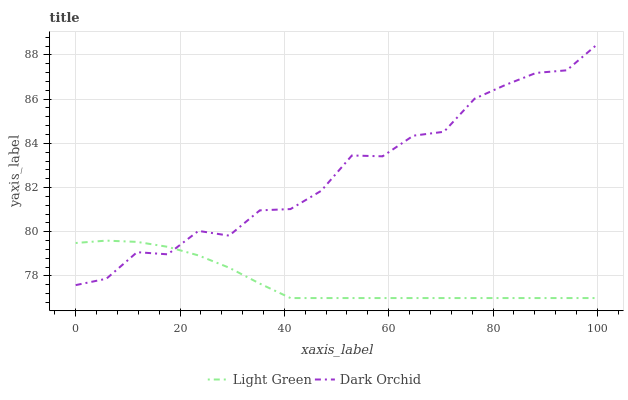Does Light Green have the minimum area under the curve?
Answer yes or no. Yes. Does Dark Orchid have the maximum area under the curve?
Answer yes or no. Yes. Does Light Green have the maximum area under the curve?
Answer yes or no. No. Is Light Green the smoothest?
Answer yes or no. Yes. Is Dark Orchid the roughest?
Answer yes or no. Yes. Is Light Green the roughest?
Answer yes or no. No. Does Dark Orchid have the highest value?
Answer yes or no. Yes. Does Light Green have the highest value?
Answer yes or no. No. Does Light Green intersect Dark Orchid?
Answer yes or no. Yes. Is Light Green less than Dark Orchid?
Answer yes or no. No. Is Light Green greater than Dark Orchid?
Answer yes or no. No. 